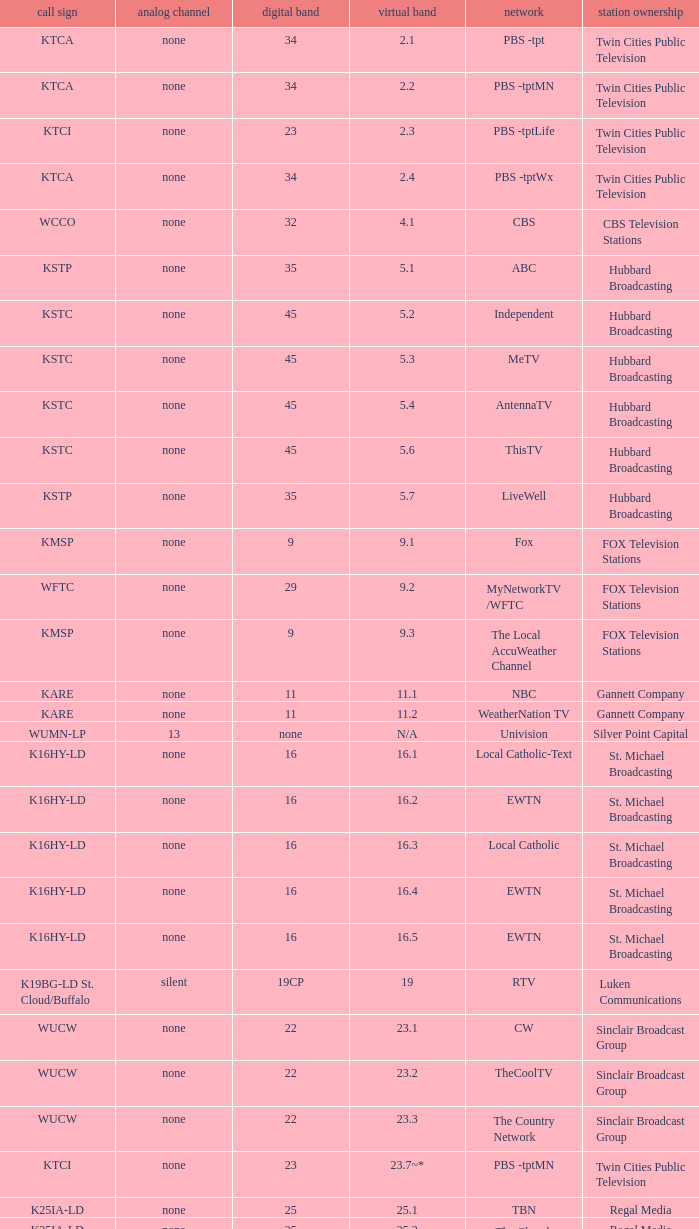Call sign of k33ln-ld, and a Virtual channel of 33.5 is what network? 3ABN Radio-Audio. Would you be able to parse every entry in this table? {'header': ['call sign', 'analog channel', 'digital band', 'virtual band', 'network', 'station ownership'], 'rows': [['KTCA', 'none', '34', '2.1', 'PBS -tpt', 'Twin Cities Public Television'], ['KTCA', 'none', '34', '2.2', 'PBS -tptMN', 'Twin Cities Public Television'], ['KTCI', 'none', '23', '2.3', 'PBS -tptLife', 'Twin Cities Public Television'], ['KTCA', 'none', '34', '2.4', 'PBS -tptWx', 'Twin Cities Public Television'], ['WCCO', 'none', '32', '4.1', 'CBS', 'CBS Television Stations'], ['KSTP', 'none', '35', '5.1', 'ABC', 'Hubbard Broadcasting'], ['KSTC', 'none', '45', '5.2', 'Independent', 'Hubbard Broadcasting'], ['KSTC', 'none', '45', '5.3', 'MeTV', 'Hubbard Broadcasting'], ['KSTC', 'none', '45', '5.4', 'AntennaTV', 'Hubbard Broadcasting'], ['KSTC', 'none', '45', '5.6', 'ThisTV', 'Hubbard Broadcasting'], ['KSTP', 'none', '35', '5.7', 'LiveWell', 'Hubbard Broadcasting'], ['KMSP', 'none', '9', '9.1', 'Fox', 'FOX Television Stations'], ['WFTC', 'none', '29', '9.2', 'MyNetworkTV /WFTC', 'FOX Television Stations'], ['KMSP', 'none', '9', '9.3', 'The Local AccuWeather Channel', 'FOX Television Stations'], ['KARE', 'none', '11', '11.1', 'NBC', 'Gannett Company'], ['KARE', 'none', '11', '11.2', 'WeatherNation TV', 'Gannett Company'], ['WUMN-LP', '13', 'none', 'N/A', 'Univision', 'Silver Point Capital'], ['K16HY-LD', 'none', '16', '16.1', 'Local Catholic-Text', 'St. Michael Broadcasting'], ['K16HY-LD', 'none', '16', '16.2', 'EWTN', 'St. Michael Broadcasting'], ['K16HY-LD', 'none', '16', '16.3', 'Local Catholic', 'St. Michael Broadcasting'], ['K16HY-LD', 'none', '16', '16.4', 'EWTN', 'St. Michael Broadcasting'], ['K16HY-LD', 'none', '16', '16.5', 'EWTN', 'St. Michael Broadcasting'], ['K19BG-LD St. Cloud/Buffalo', 'silent', '19CP', '19', 'RTV', 'Luken Communications'], ['WUCW', 'none', '22', '23.1', 'CW', 'Sinclair Broadcast Group'], ['WUCW', 'none', '22', '23.2', 'TheCoolTV', 'Sinclair Broadcast Group'], ['WUCW', 'none', '22', '23.3', 'The Country Network', 'Sinclair Broadcast Group'], ['KTCI', 'none', '23', '23.7~*', 'PBS -tptMN', 'Twin Cities Public Television'], ['K25IA-LD', 'none', '25', '25.1', 'TBN', 'Regal Media'], ['K25IA-LD', 'none', '25', '25.2', 'The Church Channel', 'Regal Media'], ['K25IA-LD', 'none', '25', '25.3', 'JCTV', 'Regal Media'], ['K25IA-LD', 'none', '25', '25.4', 'Smile Of A Child', 'Regal Media'], ['K25IA-LD', 'none', '25', '25.5', 'TBN Enlace', 'Regal Media'], ['W47CO-LD River Falls, Wisc.', 'none', '47', '28.1', 'PBS /WHWC', 'Wisconsin Public Television'], ['W47CO-LD River Falls, Wisc.', 'none', '47', '28.2', 'PBS -WISC/WHWC', 'Wisconsin Public Television'], ['W47CO-LD River Falls, Wisc.', 'none', '47', '28.3', 'PBS -Create/WHWC', 'Wisconsin Public Television'], ['WFTC', 'none', '29', '29.1', 'MyNetworkTV', 'FOX Television Stations'], ['KMSP', 'none', '9', '29.2', 'MyNetworkTV /WFTC', 'FOX Television Stations'], ['WFTC', 'none', '29', '29.3', 'Bounce TV', 'FOX Television Stations'], ['WFTC', 'none', '29', '29.4', 'Movies!', 'FOX Television Stations'], ['K33LN-LD', 'none', '33', '33.1', '3ABN', 'Three Angels Broadcasting Network'], ['K33LN-LD', 'none', '33', '33.2', '3ABN Proclaim!', 'Three Angels Broadcasting Network'], ['K33LN-LD', 'none', '33', '33.3', '3ABN Dare to Dream', 'Three Angels Broadcasting Network'], ['K33LN-LD', 'none', '33', '33.4', '3ABN Latino', 'Three Angels Broadcasting Network'], ['K33LN-LD', 'none', '33', '33.5', '3ABN Radio-Audio', 'Three Angels Broadcasting Network'], ['K33LN-LD', 'none', '33', '33.6', '3ABN Radio Latino-Audio', 'Three Angels Broadcasting Network'], ['K33LN-LD', 'none', '33', '33.7', 'Radio 74-Audio', 'Three Angels Broadcasting Network'], ['KPXM-TV', 'none', '40', '41.1', 'Ion Television', 'Ion Media Networks'], ['KPXM-TV', 'none', '40', '41.2', 'Qubo Kids', 'Ion Media Networks'], ['KPXM-TV', 'none', '40', '41.3', 'Ion Life', 'Ion Media Networks'], ['K43HB-LD', 'none', '43', '43.1', 'HSN', 'Ventana Television'], ['KHVM-LD', 'none', '48', '48.1', 'GCN - Religious', 'EICB TV'], ['KTCJ-LD', 'none', '50', '50.1', 'CTVN - Religious', 'EICB TV'], ['WDMI-LD', 'none', '31', '62.1', 'Daystar', 'Word of God Fellowship']]} 